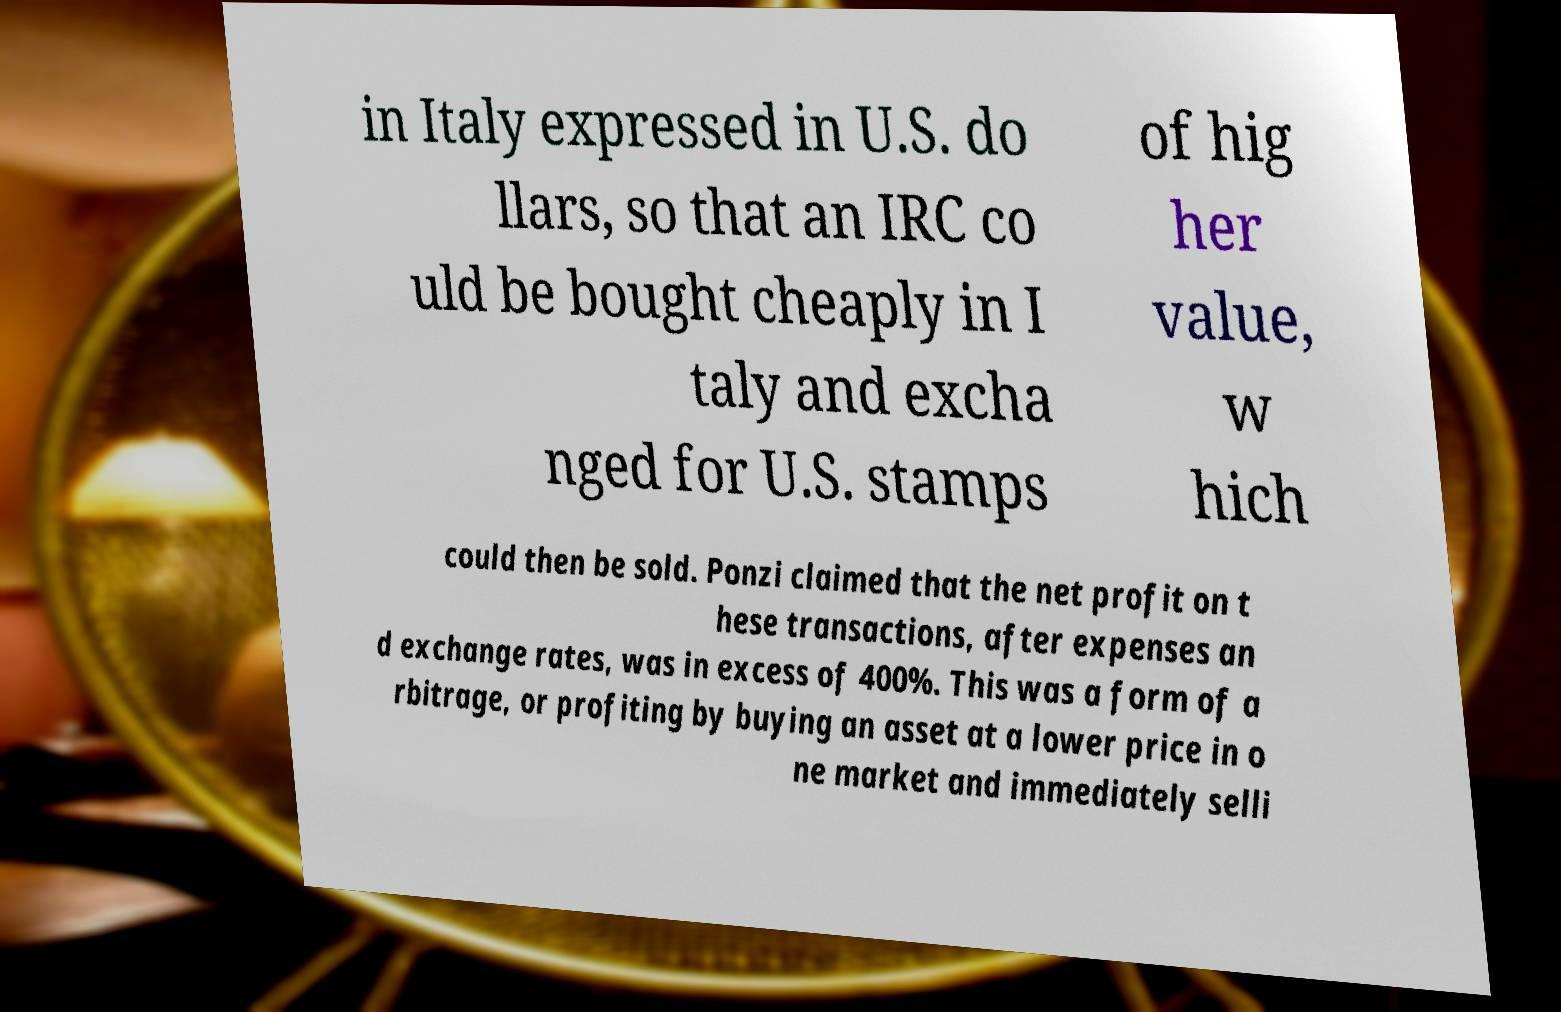I need the written content from this picture converted into text. Can you do that? in Italy expressed in U.S. do llars, so that an IRC co uld be bought cheaply in I taly and excha nged for U.S. stamps of hig her value, w hich could then be sold. Ponzi claimed that the net profit on t hese transactions, after expenses an d exchange rates, was in excess of 400%. This was a form of a rbitrage, or profiting by buying an asset at a lower price in o ne market and immediately selli 